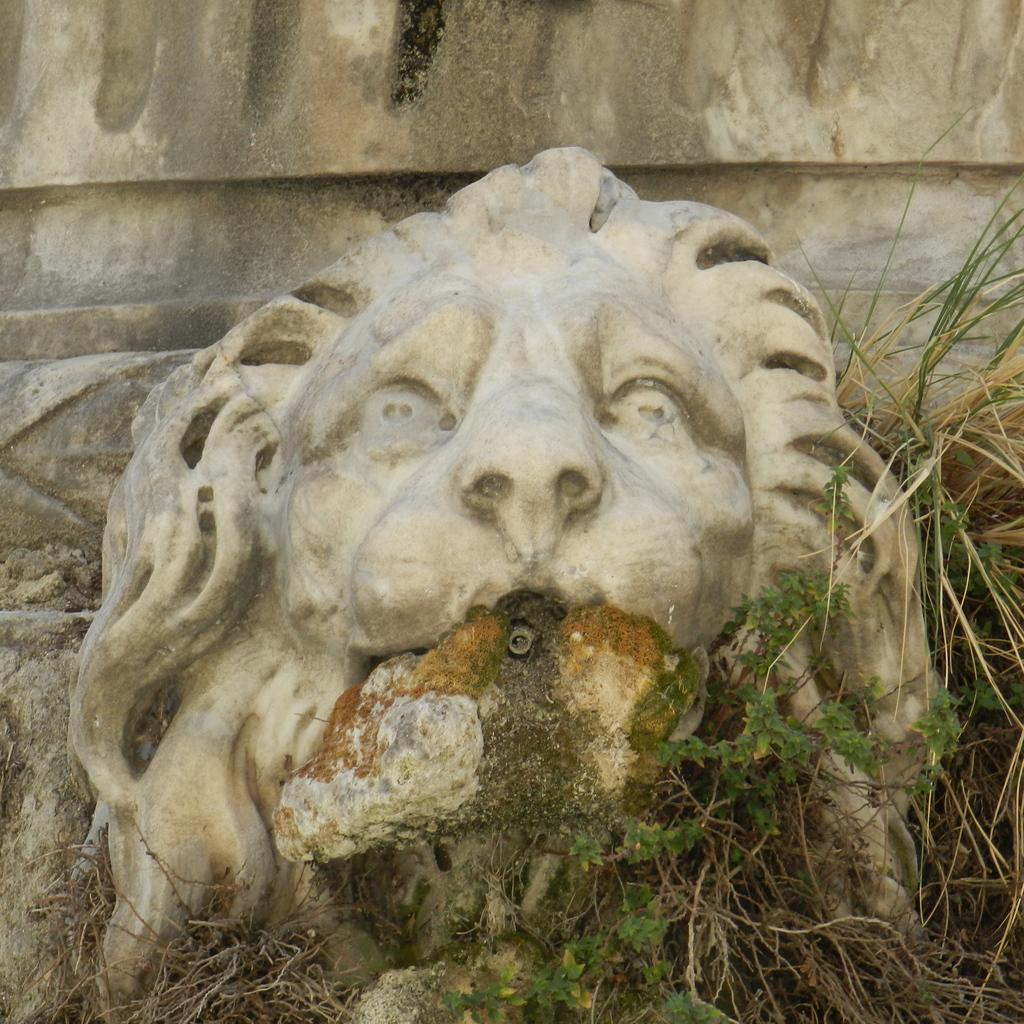What is the main subject of the image? There is a sculpture in the image. What type of natural environment is visible in the image? There is grass and plants in the image. What type of pancake is being served to the friends in the image? There are no friends or pancakes present in the image; it features a sculpture surrounded by grass and plants. 